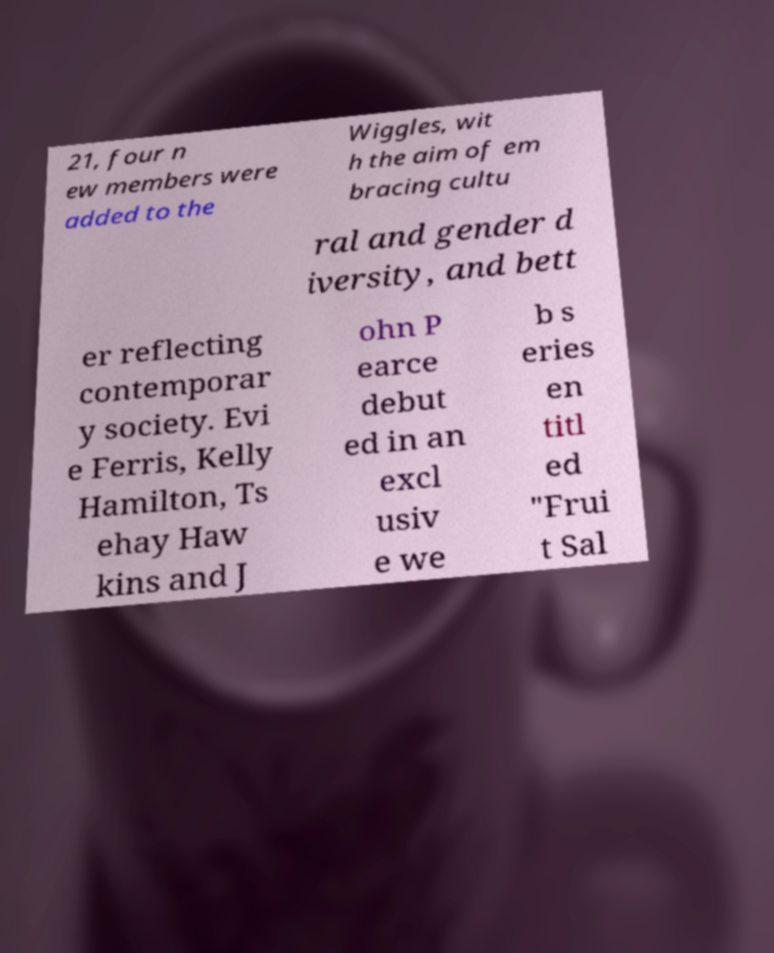Can you read and provide the text displayed in the image?This photo seems to have some interesting text. Can you extract and type it out for me? 21, four n ew members were added to the Wiggles, wit h the aim of em bracing cultu ral and gender d iversity, and bett er reflecting contemporar y society. Evi e Ferris, Kelly Hamilton, Ts ehay Haw kins and J ohn P earce debut ed in an excl usiv e we b s eries en titl ed "Frui t Sal 